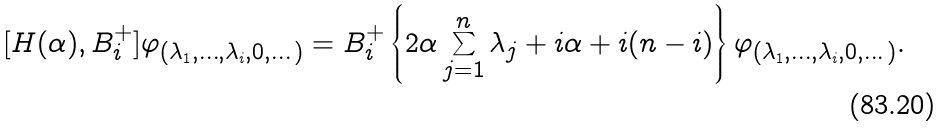Convert formula to latex. <formula><loc_0><loc_0><loc_500><loc_500>[ H ( \alpha ) , B _ { i } ^ { + } ] \varphi _ { ( \lambda _ { 1 } , \dots , \lambda _ { i } , 0 , \dots ) } = B _ { i } ^ { + } \left \{ 2 \alpha \sum _ { j = 1 } ^ { n } \lambda _ { j } + i \alpha + i ( n - i ) \right \} \varphi _ { ( \lambda _ { 1 } , \dots , \lambda _ { i } , 0 , \dots ) } .</formula> 